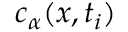Convert formula to latex. <formula><loc_0><loc_0><loc_500><loc_500>c _ { \alpha } ( x , t _ { i } )</formula> 